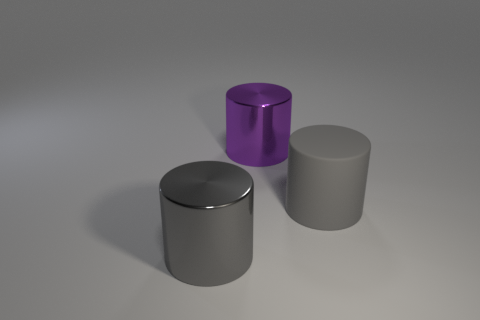Do the rubber object and the metal cylinder that is in front of the rubber thing have the same color?
Your answer should be very brief. Yes. The matte object that is the same shape as the purple shiny thing is what color?
Your answer should be compact. Gray. Is the material of the purple cylinder the same as the gray thing that is right of the purple thing?
Ensure brevity in your answer.  No. What is the color of the matte object?
Your response must be concise. Gray. The big object in front of the object on the right side of the metal thing behind the large gray shiny object is what color?
Provide a short and direct response. Gray. There is a gray matte object; is its shape the same as the metal object that is on the right side of the large gray metal cylinder?
Offer a very short reply. Yes. The cylinder that is in front of the big purple cylinder and right of the big gray metallic thing is what color?
Offer a very short reply. Gray. Are there any big gray shiny things of the same shape as the large purple thing?
Provide a short and direct response. Yes. Is there a big cylinder that is to the left of the gray cylinder that is right of the large gray shiny thing?
Offer a terse response. Yes. What number of objects are big objects left of the large gray matte thing or big gray rubber things right of the big purple shiny thing?
Offer a very short reply. 3. 